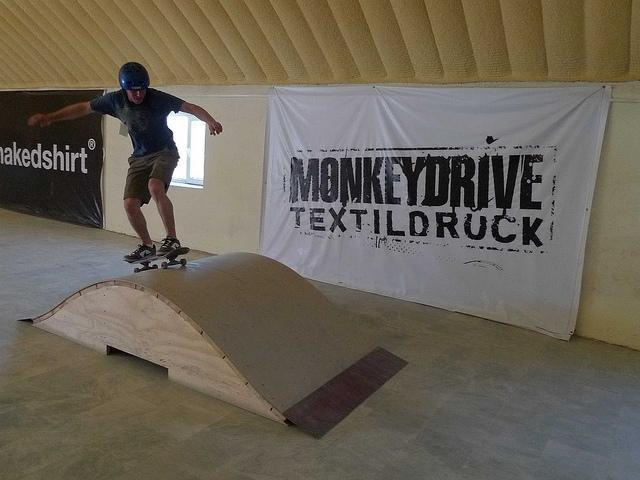How many skaters are there?
Give a very brief answer. 1. 